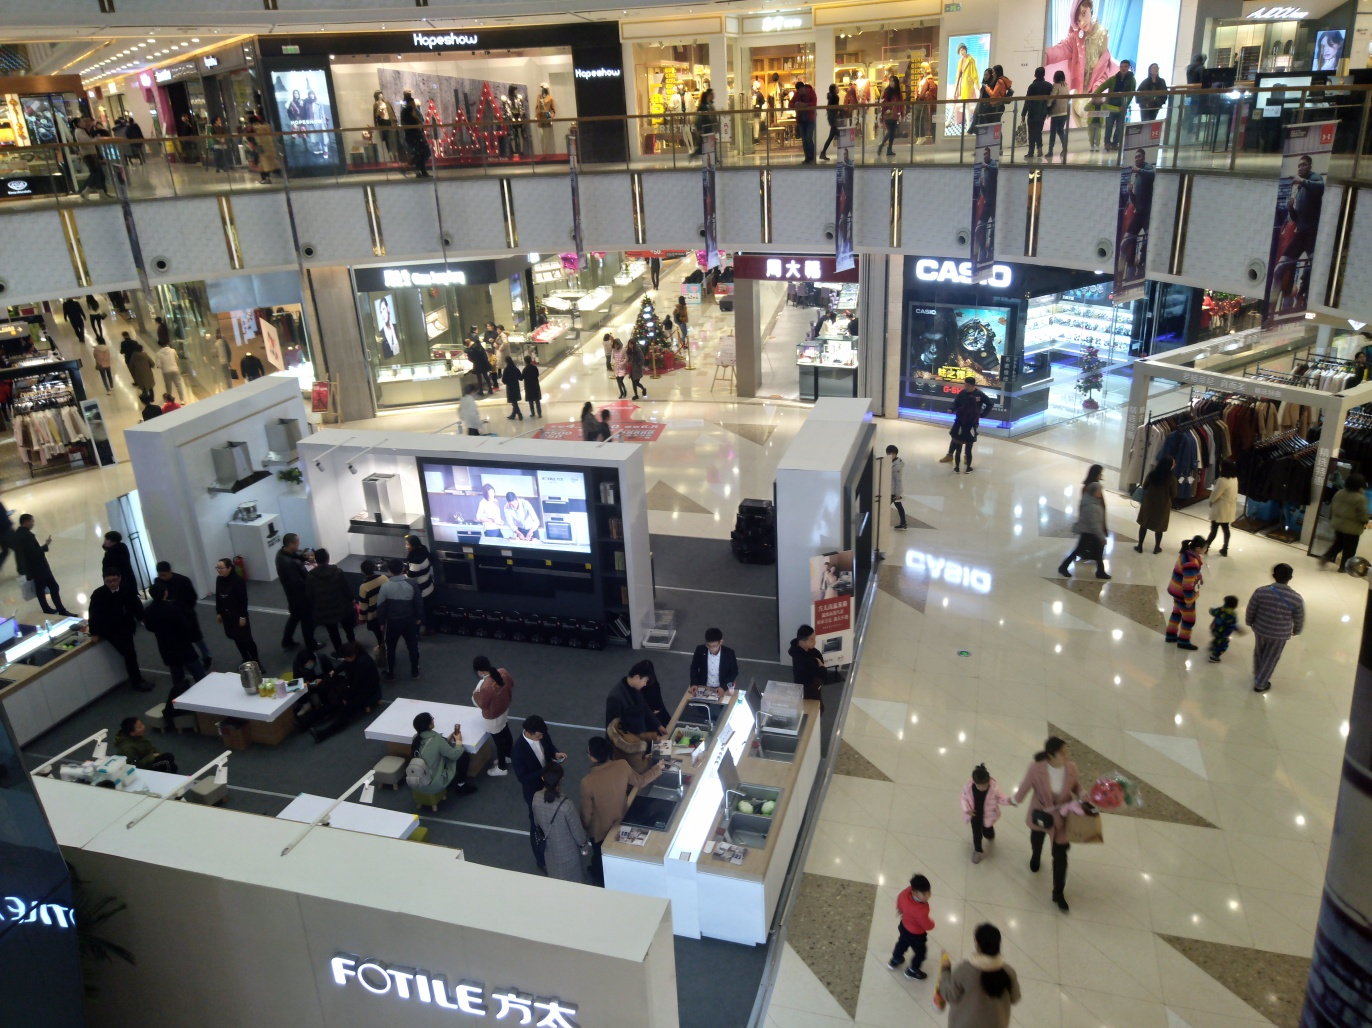Is the lighting bright in the photo? Yes, the photo depicts a brightly lit indoor mall area with natural and artificial light sources combining to create a well-illuminated environment. The overhead lights cast a warm glow, while daylight appears to be coming in from the upper levels, further enhancing the brightness of the setting. 